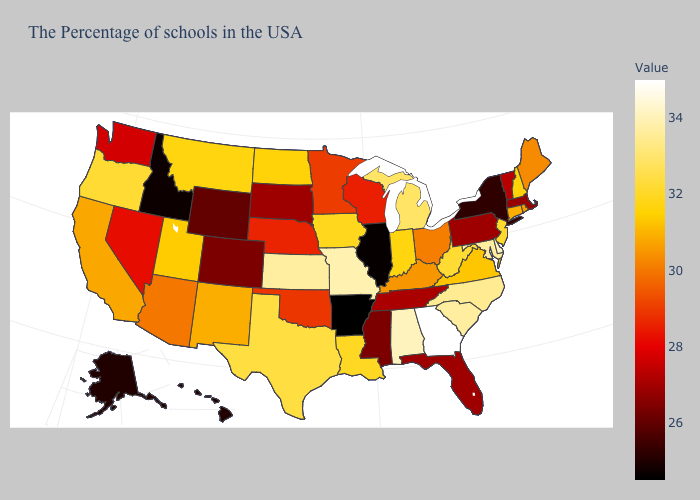Is the legend a continuous bar?
Concise answer only. Yes. Does Tennessee have a lower value than Oregon?
Quick response, please. Yes. 